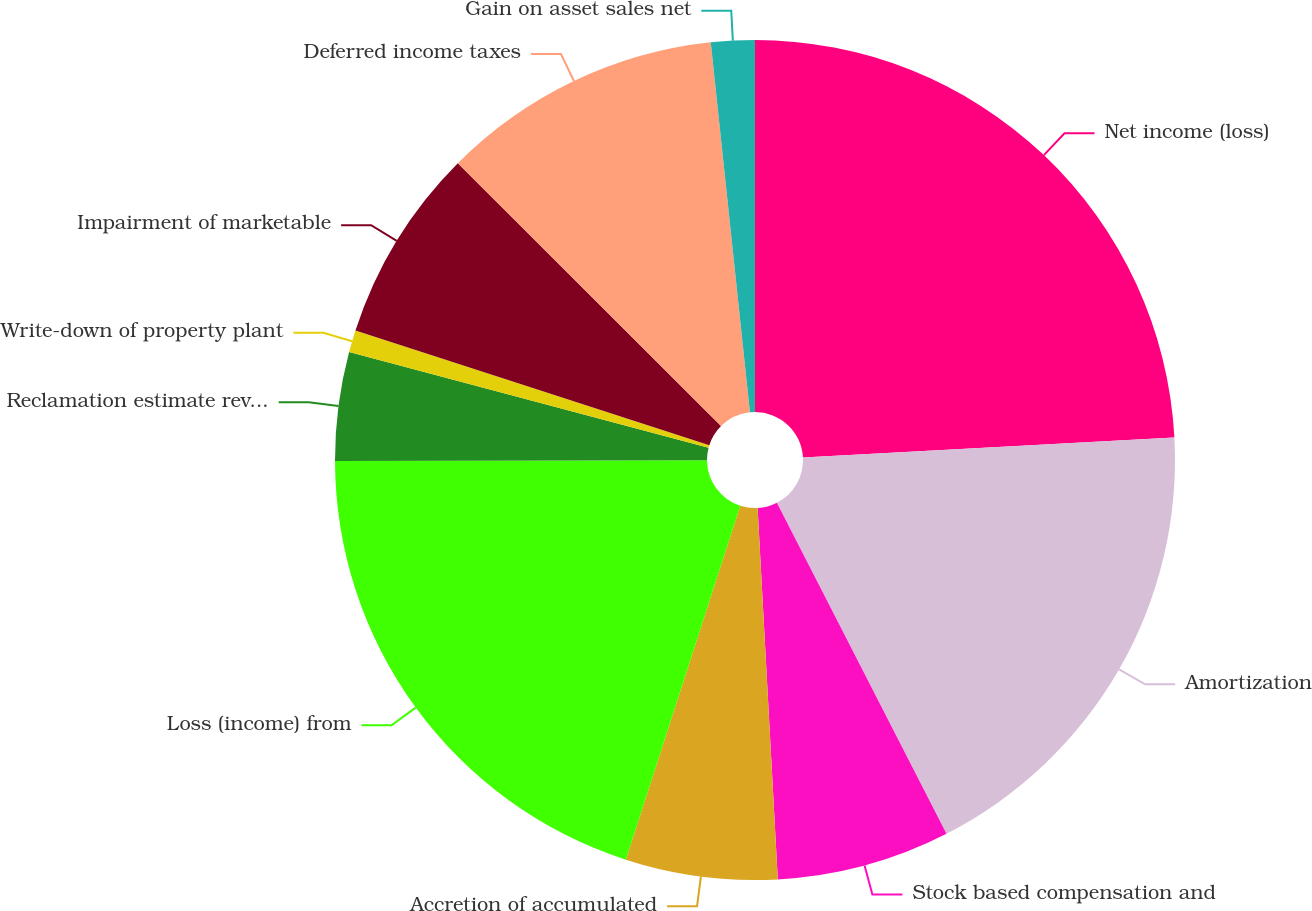<chart> <loc_0><loc_0><loc_500><loc_500><pie_chart><fcel>Net income (loss)<fcel>Amortization<fcel>Stock based compensation and<fcel>Accretion of accumulated<fcel>Loss (income) from<fcel>Reclamation estimate revisions<fcel>Write-down of property plant<fcel>Impairment of marketable<fcel>Deferred income taxes<fcel>Gain on asset sales net<nl><fcel>24.14%<fcel>18.32%<fcel>6.67%<fcel>5.84%<fcel>19.98%<fcel>4.18%<fcel>0.85%<fcel>7.5%<fcel>10.83%<fcel>1.68%<nl></chart> 